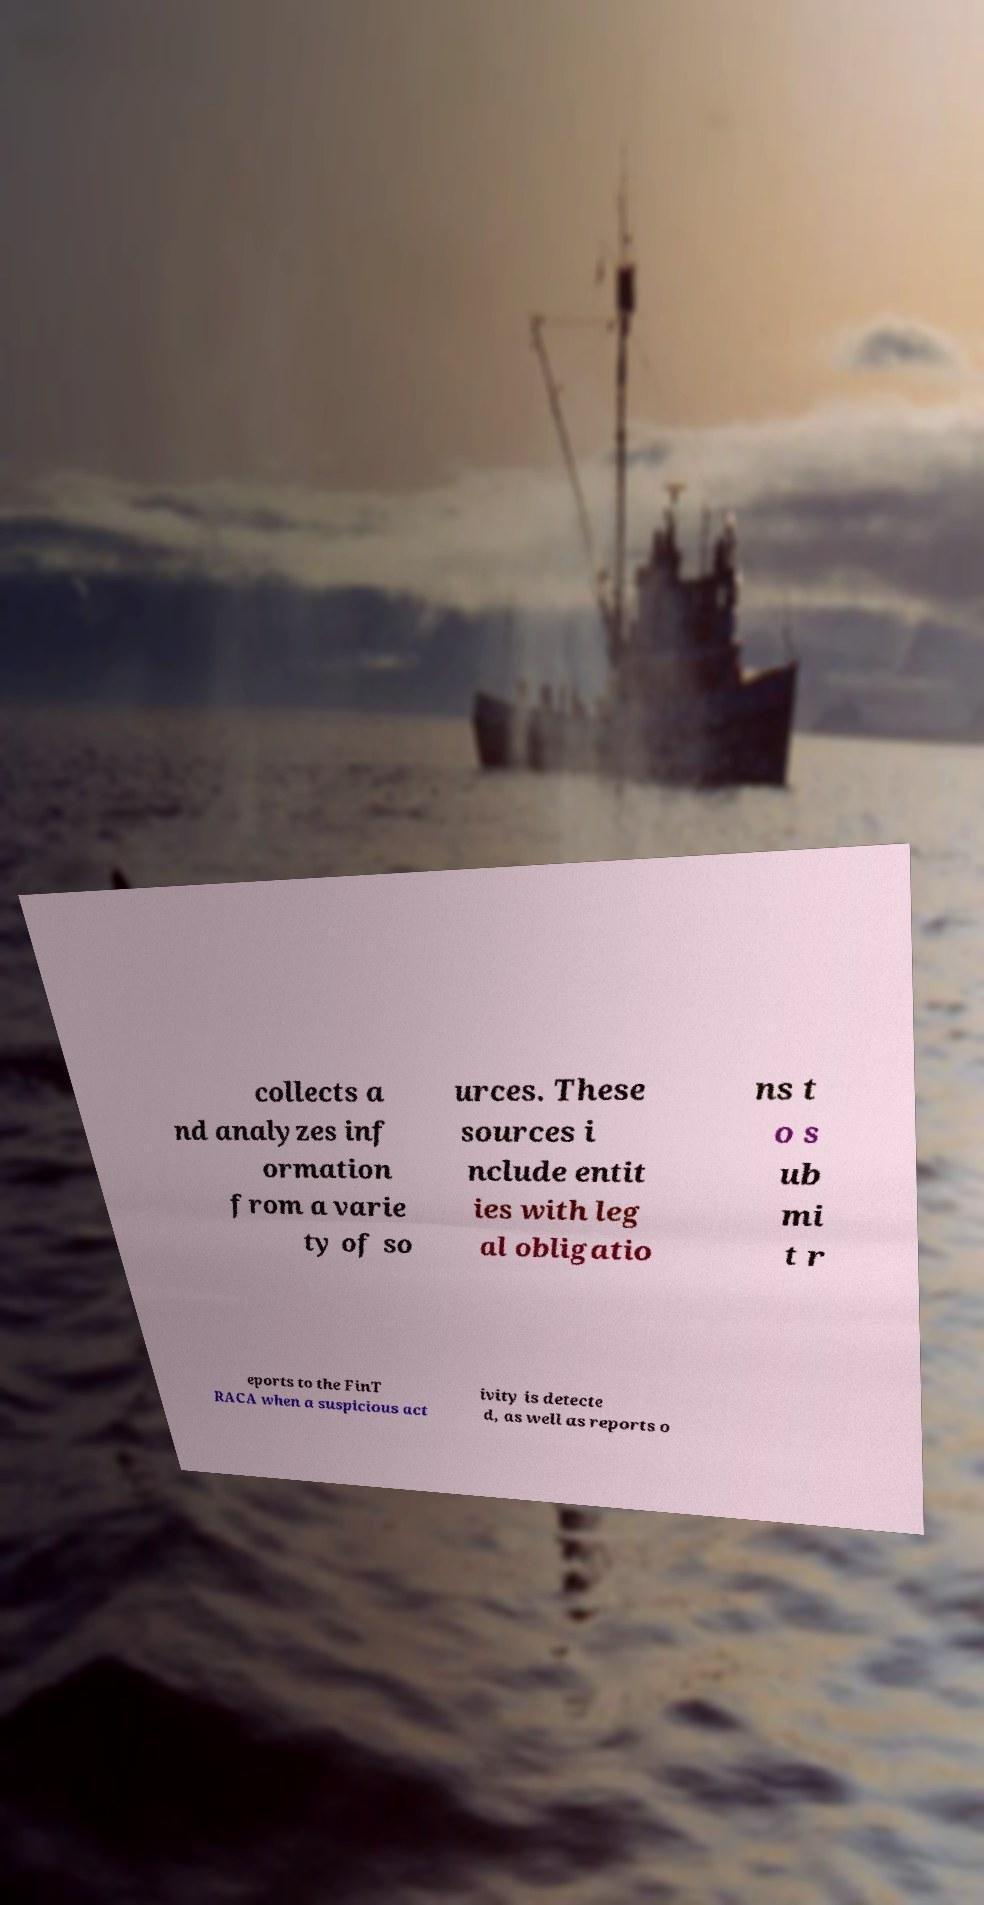Please read and relay the text visible in this image. What does it say? collects a nd analyzes inf ormation from a varie ty of so urces. These sources i nclude entit ies with leg al obligatio ns t o s ub mi t r eports to the FinT RACA when a suspicious act ivity is detecte d, as well as reports o 